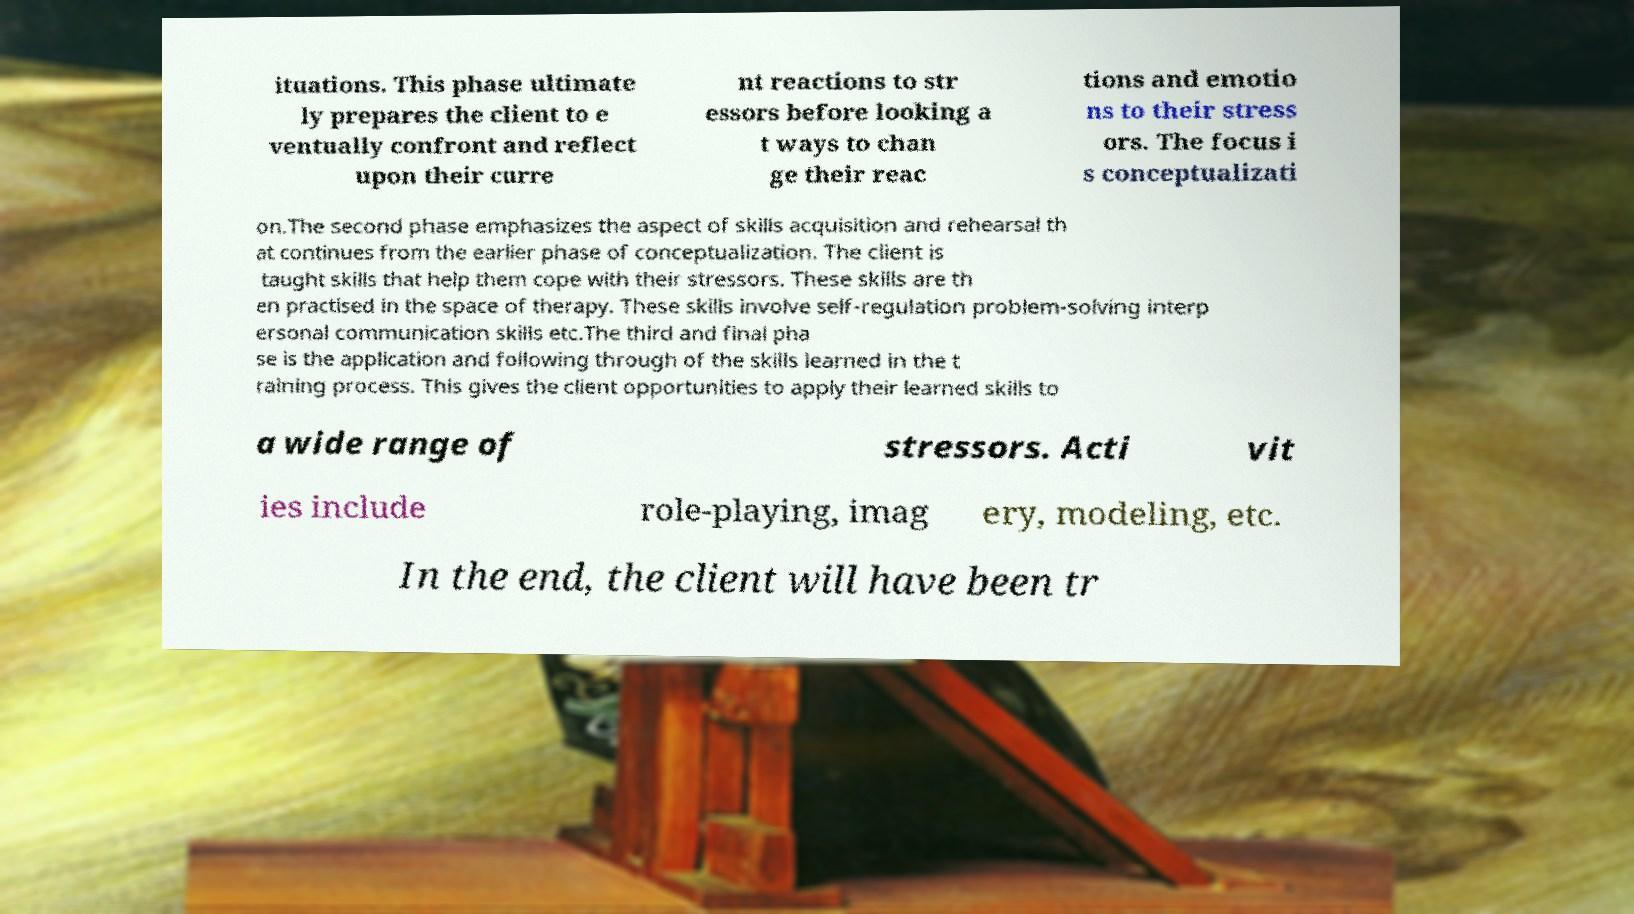For documentation purposes, I need the text within this image transcribed. Could you provide that? ituations. This phase ultimate ly prepares the client to e ventually confront and reflect upon their curre nt reactions to str essors before looking a t ways to chan ge their reac tions and emotio ns to their stress ors. The focus i s conceptualizati on.The second phase emphasizes the aspect of skills acquisition and rehearsal th at continues from the earlier phase of conceptualization. The client is taught skills that help them cope with their stressors. These skills are th en practised in the space of therapy. These skills involve self-regulation problem-solving interp ersonal communication skills etc.The third and final pha se is the application and following through of the skills learned in the t raining process. This gives the client opportunities to apply their learned skills to a wide range of stressors. Acti vit ies include role-playing, imag ery, modeling, etc. In the end, the client will have been tr 